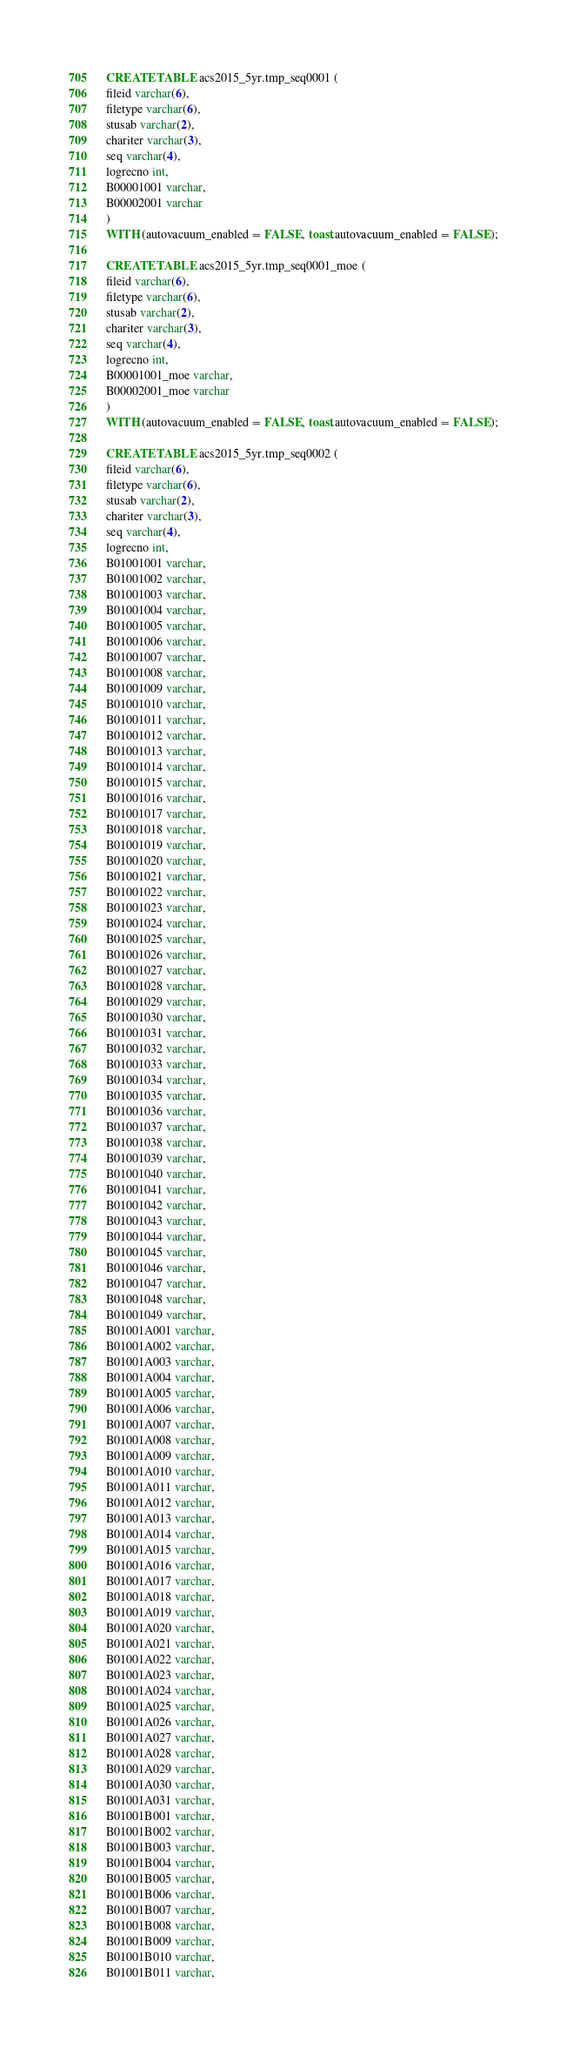<code> <loc_0><loc_0><loc_500><loc_500><_SQL_>CREATE TABLE acs2015_5yr.tmp_seq0001 (
fileid varchar(6),
filetype varchar(6),
stusab varchar(2),
chariter varchar(3),
seq varchar(4),
logrecno int,
B00001001 varchar,
B00002001 varchar
)
WITH (autovacuum_enabled = FALSE, toast.autovacuum_enabled = FALSE);

CREATE TABLE acs2015_5yr.tmp_seq0001_moe (
fileid varchar(6),
filetype varchar(6),
stusab varchar(2),
chariter varchar(3),
seq varchar(4),
logrecno int,
B00001001_moe varchar,
B00002001_moe varchar
)
WITH (autovacuum_enabled = FALSE, toast.autovacuum_enabled = FALSE);

CREATE TABLE acs2015_5yr.tmp_seq0002 (
fileid varchar(6),
filetype varchar(6),
stusab varchar(2),
chariter varchar(3),
seq varchar(4),
logrecno int,
B01001001 varchar,
B01001002 varchar,
B01001003 varchar,
B01001004 varchar,
B01001005 varchar,
B01001006 varchar,
B01001007 varchar,
B01001008 varchar,
B01001009 varchar,
B01001010 varchar,
B01001011 varchar,
B01001012 varchar,
B01001013 varchar,
B01001014 varchar,
B01001015 varchar,
B01001016 varchar,
B01001017 varchar,
B01001018 varchar,
B01001019 varchar,
B01001020 varchar,
B01001021 varchar,
B01001022 varchar,
B01001023 varchar,
B01001024 varchar,
B01001025 varchar,
B01001026 varchar,
B01001027 varchar,
B01001028 varchar,
B01001029 varchar,
B01001030 varchar,
B01001031 varchar,
B01001032 varchar,
B01001033 varchar,
B01001034 varchar,
B01001035 varchar,
B01001036 varchar,
B01001037 varchar,
B01001038 varchar,
B01001039 varchar,
B01001040 varchar,
B01001041 varchar,
B01001042 varchar,
B01001043 varchar,
B01001044 varchar,
B01001045 varchar,
B01001046 varchar,
B01001047 varchar,
B01001048 varchar,
B01001049 varchar,
B01001A001 varchar,
B01001A002 varchar,
B01001A003 varchar,
B01001A004 varchar,
B01001A005 varchar,
B01001A006 varchar,
B01001A007 varchar,
B01001A008 varchar,
B01001A009 varchar,
B01001A010 varchar,
B01001A011 varchar,
B01001A012 varchar,
B01001A013 varchar,
B01001A014 varchar,
B01001A015 varchar,
B01001A016 varchar,
B01001A017 varchar,
B01001A018 varchar,
B01001A019 varchar,
B01001A020 varchar,
B01001A021 varchar,
B01001A022 varchar,
B01001A023 varchar,
B01001A024 varchar,
B01001A025 varchar,
B01001A026 varchar,
B01001A027 varchar,
B01001A028 varchar,
B01001A029 varchar,
B01001A030 varchar,
B01001A031 varchar,
B01001B001 varchar,
B01001B002 varchar,
B01001B003 varchar,
B01001B004 varchar,
B01001B005 varchar,
B01001B006 varchar,
B01001B007 varchar,
B01001B008 varchar,
B01001B009 varchar,
B01001B010 varchar,
B01001B011 varchar,</code> 